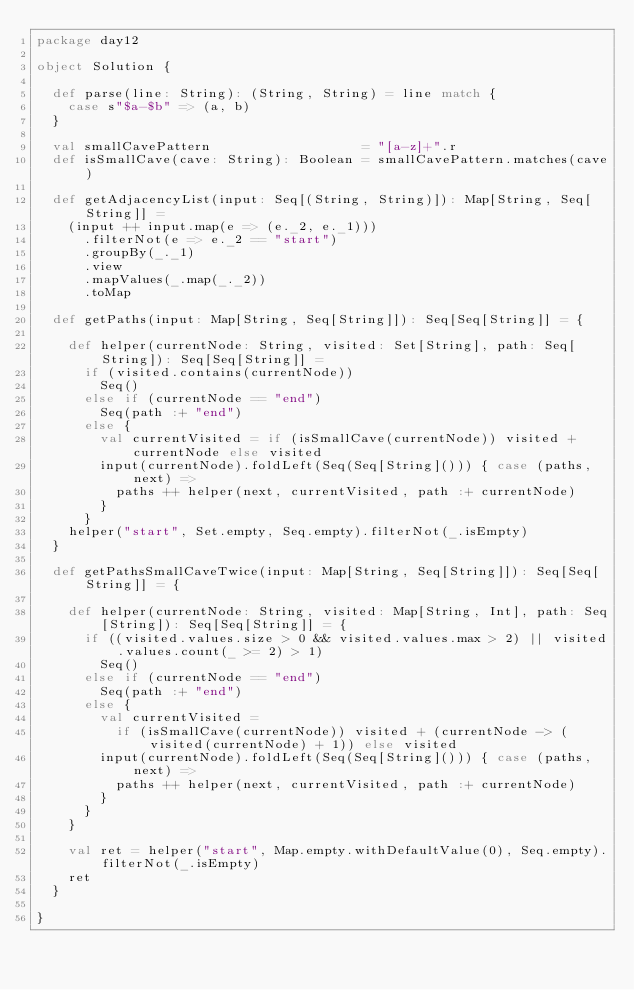<code> <loc_0><loc_0><loc_500><loc_500><_Scala_>package day12

object Solution {

  def parse(line: String): (String, String) = line match {
    case s"$a-$b" => (a, b)
  }

  val smallCavePattern                   = "[a-z]+".r
  def isSmallCave(cave: String): Boolean = smallCavePattern.matches(cave)

  def getAdjacencyList(input: Seq[(String, String)]): Map[String, Seq[String]] =
    (input ++ input.map(e => (e._2, e._1)))
      .filterNot(e => e._2 == "start")
      .groupBy(_._1)
      .view
      .mapValues(_.map(_._2))
      .toMap

  def getPaths(input: Map[String, Seq[String]]): Seq[Seq[String]] = {

    def helper(currentNode: String, visited: Set[String], path: Seq[String]): Seq[Seq[String]] =
      if (visited.contains(currentNode))
        Seq()
      else if (currentNode == "end")
        Seq(path :+ "end")
      else {
        val currentVisited = if (isSmallCave(currentNode)) visited + currentNode else visited
        input(currentNode).foldLeft(Seq(Seq[String]())) { case (paths, next) =>
          paths ++ helper(next, currentVisited, path :+ currentNode)
        }
      }
    helper("start", Set.empty, Seq.empty).filterNot(_.isEmpty)
  }

  def getPathsSmallCaveTwice(input: Map[String, Seq[String]]): Seq[Seq[String]] = {

    def helper(currentNode: String, visited: Map[String, Int], path: Seq[String]): Seq[Seq[String]] = {
      if ((visited.values.size > 0 && visited.values.max > 2) || visited.values.count(_ >= 2) > 1)
        Seq()
      else if (currentNode == "end")
        Seq(path :+ "end")
      else {
        val currentVisited =
          if (isSmallCave(currentNode)) visited + (currentNode -> (visited(currentNode) + 1)) else visited
        input(currentNode).foldLeft(Seq(Seq[String]())) { case (paths, next) =>
          paths ++ helper(next, currentVisited, path :+ currentNode)
        }
      }
    }

    val ret = helper("start", Map.empty.withDefaultValue(0), Seq.empty).filterNot(_.isEmpty)
    ret
  }

}
</code> 